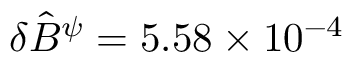<formula> <loc_0><loc_0><loc_500><loc_500>\delta \hat { B } ^ { \psi } = 5 . 5 8 \times 1 0 ^ { - 4 }</formula> 